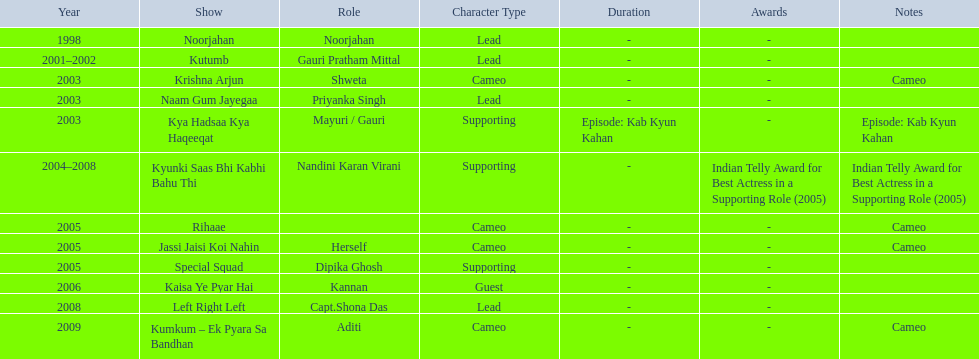In 1998 what was the role of gauri pradhan tejwani? Noorjahan. In 2003 what show did gauri have a cameo in? Krishna Arjun. Gauri was apart of which television show for the longest? Kyunki Saas Bhi Kabhi Bahu Thi. 